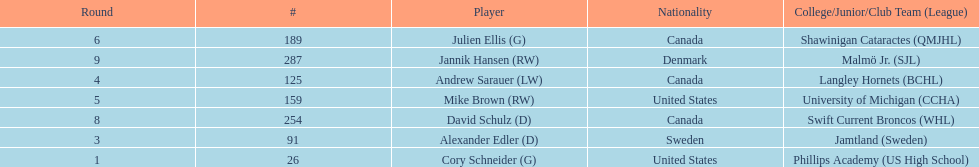What number of players have canada listed as their nationality? 3. 